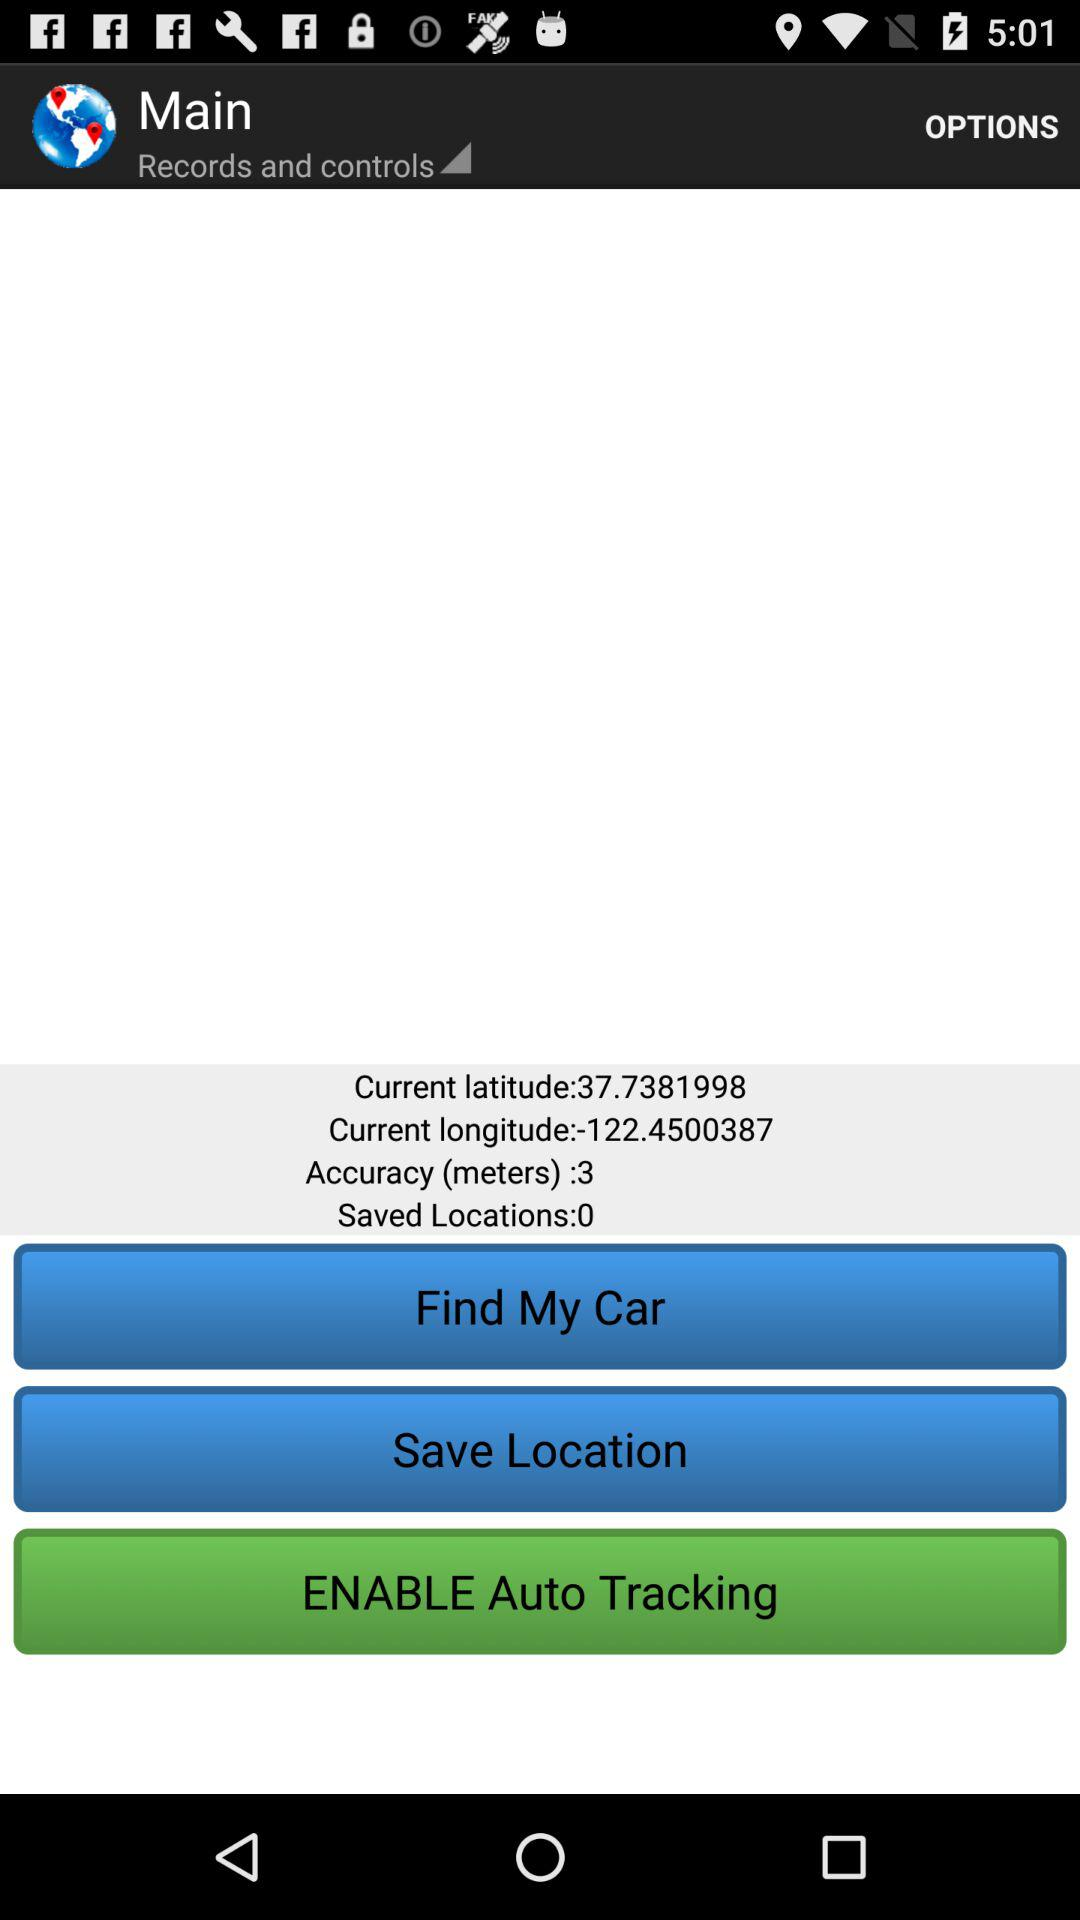How many saved locations are there? There are 0 saved locations. 